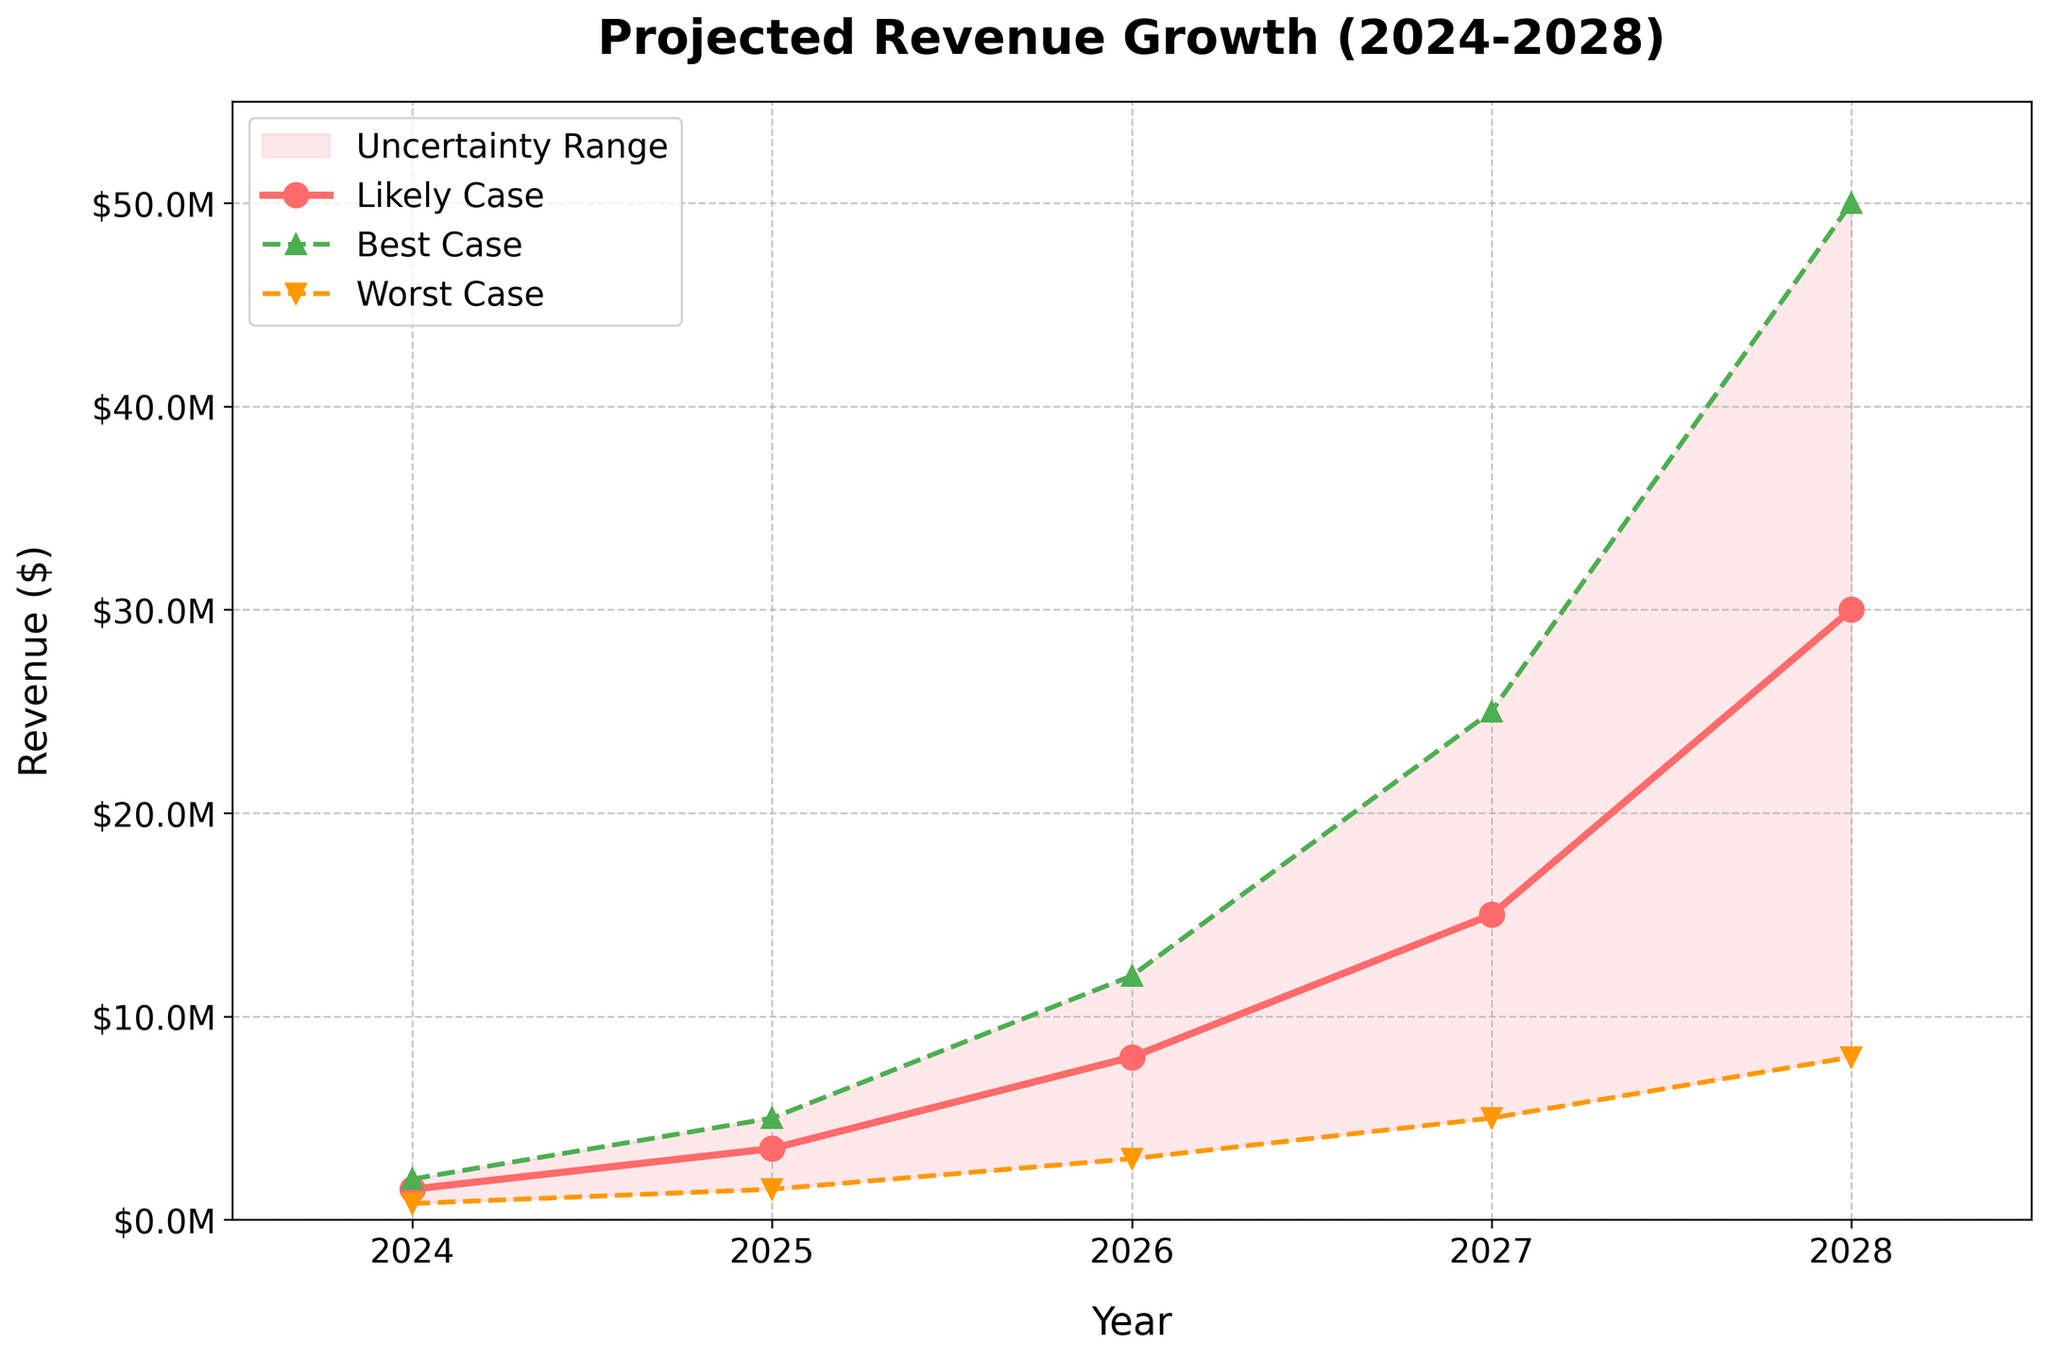What is the title of the chart? The title is located at the top of the chart, and it is meant to give a summary of what the chart shows. It reads "Projected Revenue Growth (2024-2028)”.
Answer: Projected Revenue Growth (2024-2028) What is the likely case revenue in 2027? To find the likely case revenue in 2027, locate the point corresponding to the likely case line (the solid line) where it intersects the vertical line for 2027. The likely case revenue in 2027 is labeled or can be inferred from its position.
Answer: $15,000,000 What is the difference between the best-case and worst-case scenario in 2028? First, find the best-case revenue for 2028 and the worst-case revenue for 2028 from the chart. Best-case is $50,000,000 and worst-case is $8,000,000. Then, subtract the worst-case from the best-case: $50,000,000 - $8,000,000 = $42,000,000
Answer: $42,000,000 How does the revenue change for the likely case from 2024 to 2025? To determine the revenue change, identify the likely case revenues for both years. In 2024, it is $1,500,000 and in 2025, it is $3,500,000. Subtract the 2024 revenue from the 2025 revenue: $3,500,000 - $1,500,000 = $2,000,000
Answer: $2,000,000 In which year is the uncertainty range the widest? To determine this, you need to visually compare the range between the best-case and worst-case scenarios for each year. The widest range is where the gap between the best and worst cases is the largest. In 2028, the range is $50,000,000 - $8,000,000 = $42,000,000, which is the widest.
Answer: 2028 What year shows the smallest revenue in the worst-case scenario? Locate the worst-case scenario line (the dashed line with markers) and find the lowest point on that line. The lowest revenue value for the worst-case scenario is at 2024 with $800,000.
Answer: 2024 What is the average best-case revenue from 2024 to 2028? Sum the best-case revenues for each year and divide by the number of years: (2,000,000 + 5,000,000 + 12,000,000 + 25,000,000 + 50,000,000) / 5. This calculation results in an average.
Answer: $18,800,000 Which year has the greatest increase in likely case revenue compared to the previous year? First, calculate the year-over-year increase for the likely case: 2025-2024 = $2,000,000, 2026-2025 = $4,500,000, 2027-2026 = $7,000,000, 2028-2027 = $15,000,000. The greatest increase is from 2027 to 2028 with $15,000,000.
Answer: 2028 Is there any year where the likely case and best-case scenarios have the same revenue projection? Compare the points on the likely case line (solid line) and the best-case line (dashed line with triangular markers) for all years. None of the years have the same revenue in the likely and best cases.
Answer: No 